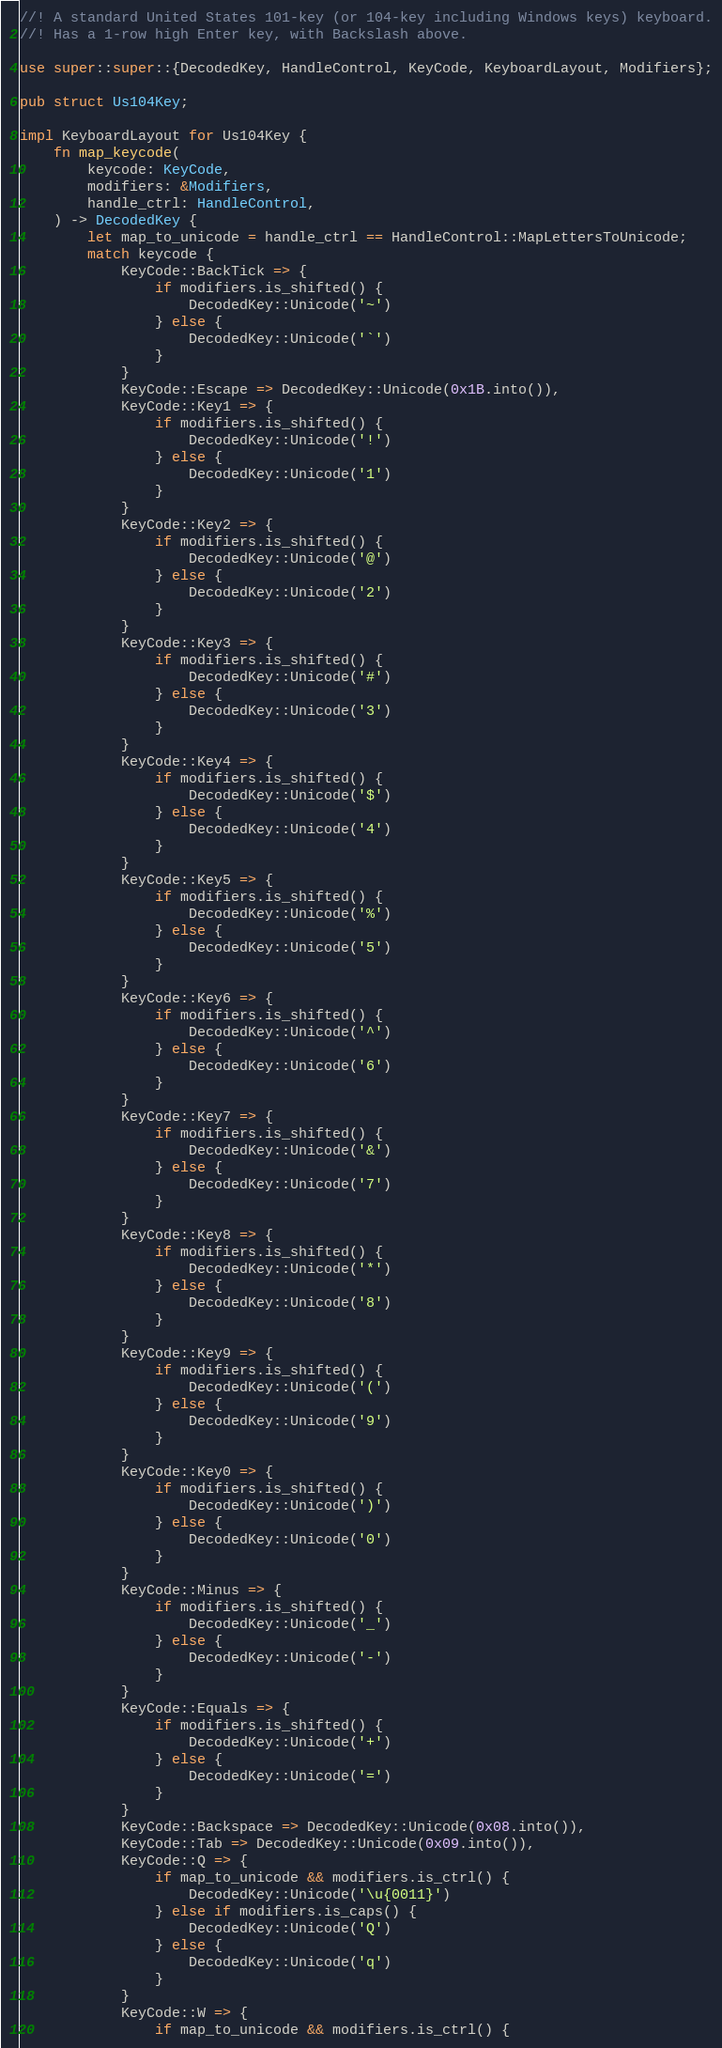Convert code to text. <code><loc_0><loc_0><loc_500><loc_500><_Rust_>//! A standard United States 101-key (or 104-key including Windows keys) keyboard.
//! Has a 1-row high Enter key, with Backslash above.

use super::super::{DecodedKey, HandleControl, KeyCode, KeyboardLayout, Modifiers};

pub struct Us104Key;

impl KeyboardLayout for Us104Key {
    fn map_keycode(
        keycode: KeyCode,
        modifiers: &Modifiers,
        handle_ctrl: HandleControl,
    ) -> DecodedKey {
        let map_to_unicode = handle_ctrl == HandleControl::MapLettersToUnicode;
        match keycode {
            KeyCode::BackTick => {
                if modifiers.is_shifted() {
                    DecodedKey::Unicode('~')
                } else {
                    DecodedKey::Unicode('`')
                }
            }
            KeyCode::Escape => DecodedKey::Unicode(0x1B.into()),
            KeyCode::Key1 => {
                if modifiers.is_shifted() {
                    DecodedKey::Unicode('!')
                } else {
                    DecodedKey::Unicode('1')
                }
            }
            KeyCode::Key2 => {
                if modifiers.is_shifted() {
                    DecodedKey::Unicode('@')
                } else {
                    DecodedKey::Unicode('2')
                }
            }
            KeyCode::Key3 => {
                if modifiers.is_shifted() {
                    DecodedKey::Unicode('#')
                } else {
                    DecodedKey::Unicode('3')
                }
            }
            KeyCode::Key4 => {
                if modifiers.is_shifted() {
                    DecodedKey::Unicode('$')
                } else {
                    DecodedKey::Unicode('4')
                }
            }
            KeyCode::Key5 => {
                if modifiers.is_shifted() {
                    DecodedKey::Unicode('%')
                } else {
                    DecodedKey::Unicode('5')
                }
            }
            KeyCode::Key6 => {
                if modifiers.is_shifted() {
                    DecodedKey::Unicode('^')
                } else {
                    DecodedKey::Unicode('6')
                }
            }
            KeyCode::Key7 => {
                if modifiers.is_shifted() {
                    DecodedKey::Unicode('&')
                } else {
                    DecodedKey::Unicode('7')
                }
            }
            KeyCode::Key8 => {
                if modifiers.is_shifted() {
                    DecodedKey::Unicode('*')
                } else {
                    DecodedKey::Unicode('8')
                }
            }
            KeyCode::Key9 => {
                if modifiers.is_shifted() {
                    DecodedKey::Unicode('(')
                } else {
                    DecodedKey::Unicode('9')
                }
            }
            KeyCode::Key0 => {
                if modifiers.is_shifted() {
                    DecodedKey::Unicode(')')
                } else {
                    DecodedKey::Unicode('0')
                }
            }
            KeyCode::Minus => {
                if modifiers.is_shifted() {
                    DecodedKey::Unicode('_')
                } else {
                    DecodedKey::Unicode('-')
                }
            }
            KeyCode::Equals => {
                if modifiers.is_shifted() {
                    DecodedKey::Unicode('+')
                } else {
                    DecodedKey::Unicode('=')
                }
            }
            KeyCode::Backspace => DecodedKey::Unicode(0x08.into()),
            KeyCode::Tab => DecodedKey::Unicode(0x09.into()),
            KeyCode::Q => {
                if map_to_unicode && modifiers.is_ctrl() {
                    DecodedKey::Unicode('\u{0011}')
                } else if modifiers.is_caps() {
                    DecodedKey::Unicode('Q')
                } else {
                    DecodedKey::Unicode('q')
                }
            }
            KeyCode::W => {
                if map_to_unicode && modifiers.is_ctrl() {</code> 